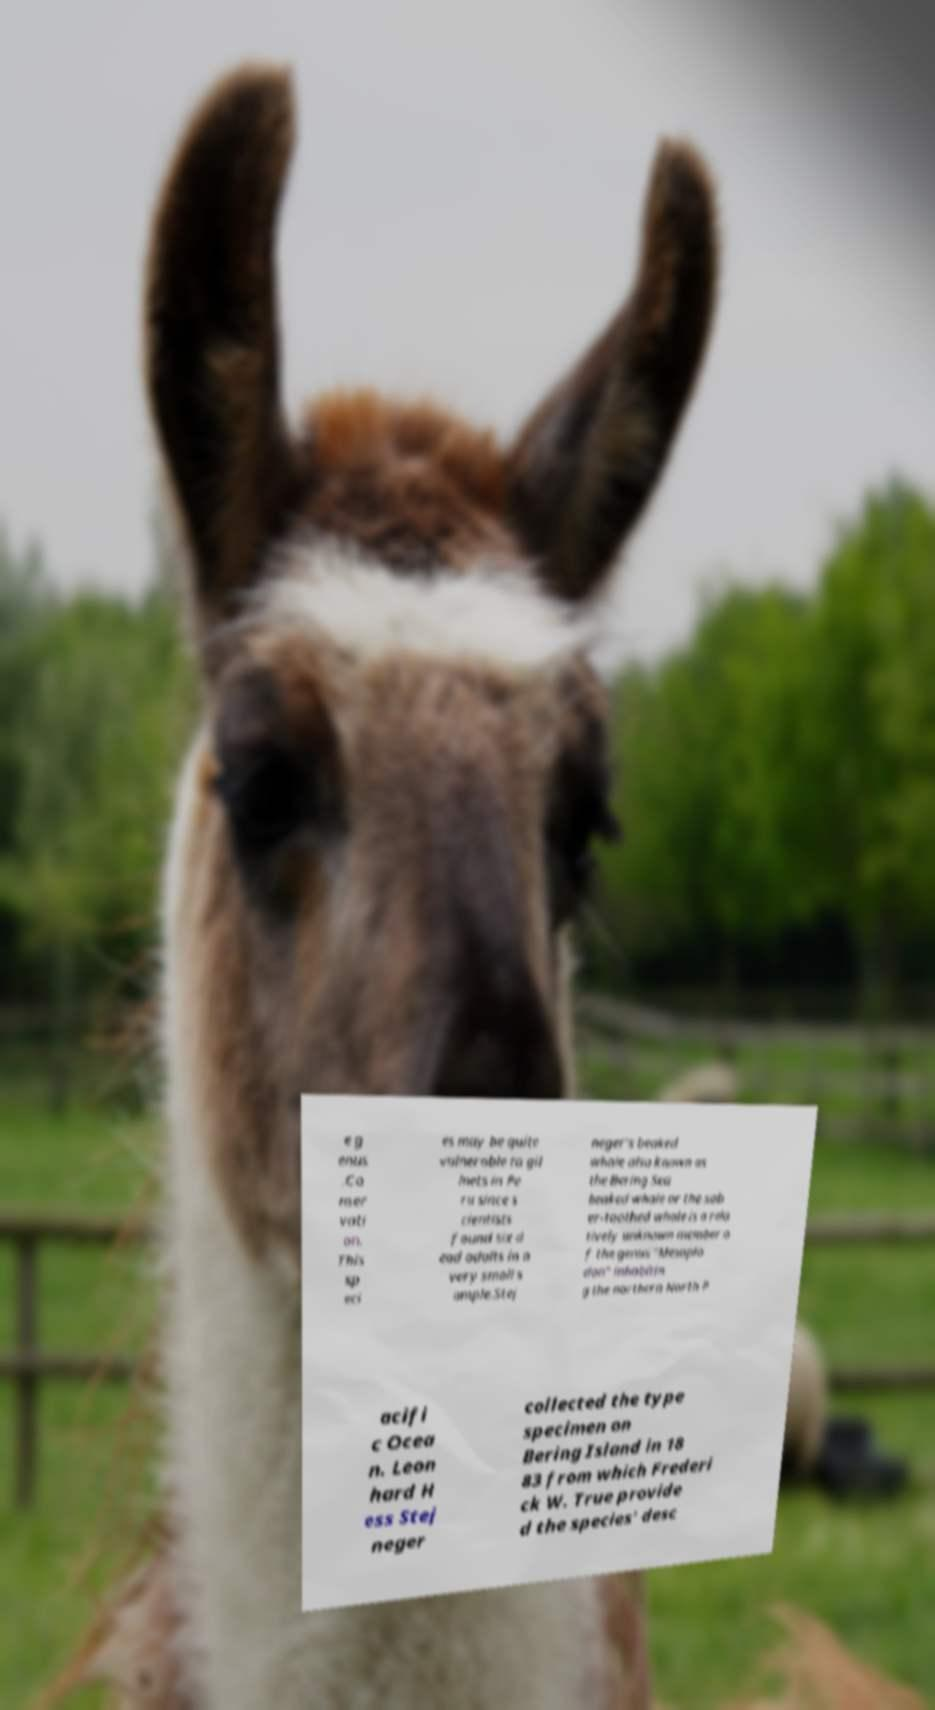Please read and relay the text visible in this image. What does it say? e g enus .Co nser vati on. This sp eci es may be quite vulnerable to gil lnets in Pe ru since s cientists found six d ead adults in a very small s ample.Stej neger's beaked whale also known as the Bering Sea beaked whale or the sab er-toothed whale is a rela tively unknown member o f the genus "Mesoplo don" inhabitin g the northern North P acifi c Ocea n. Leon hard H ess Stej neger collected the type specimen on Bering Island in 18 83 from which Frederi ck W. True provide d the species' desc 